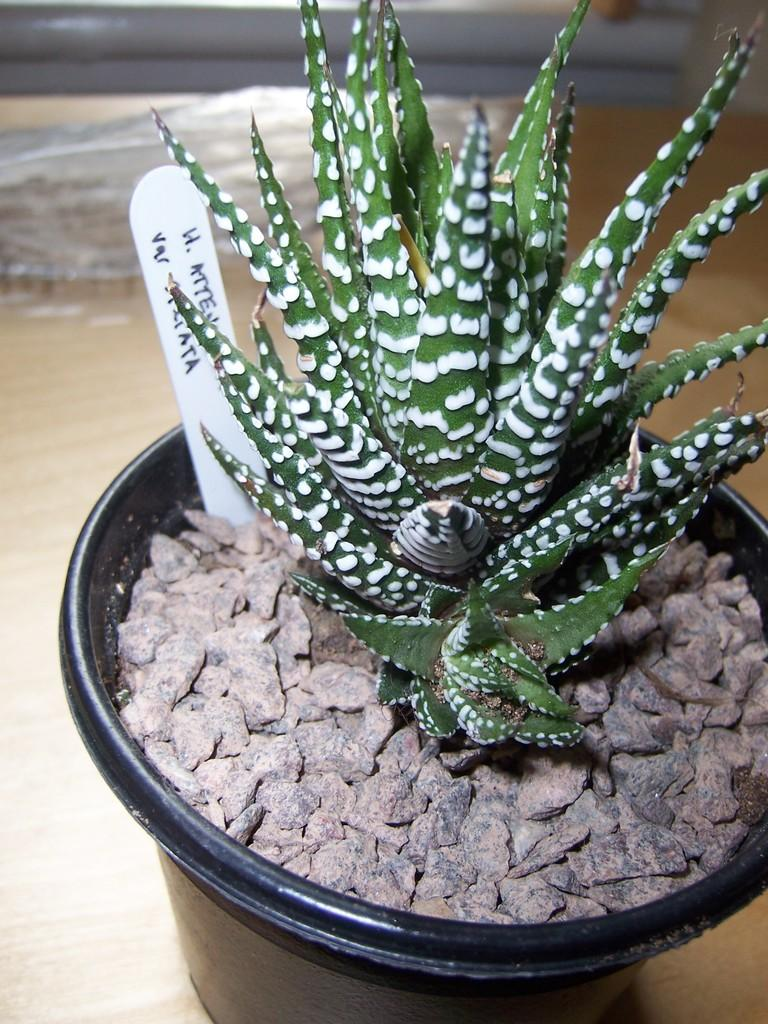What is the main subject in the middle of the image? There is a houseplant in the middle of the image. What is located at the bottom of the image? At the bottom of the image, there is a pot. What is inside the pot? The pot contains stones. What is attached to the pot? There is a poster on the pot. What is growing in the pot? There is a plant in the pot. What can be seen in the background of the image? There is a floor visible in the background of the image. What type of government is depicted on the poster in the image? There is no government depicted on the poster in the image; it is a poster on a pot containing a plant. How does the liquid in the pot affect the growth of the plant? There is no liquid present in the pot; it contains stones and a plant. 